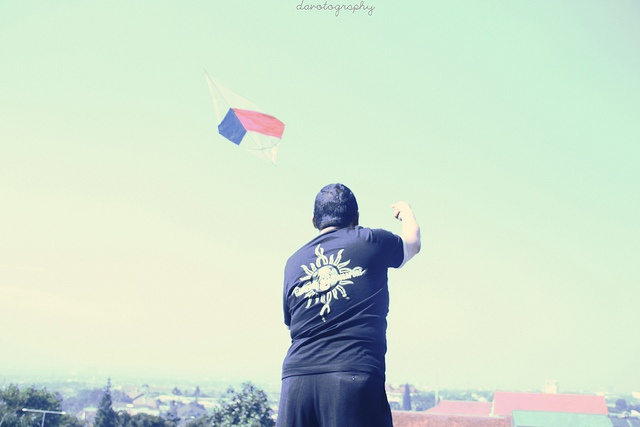Describe the objects in this image and their specific colors. I can see people in beige, navy, gray, and darkblue tones and kite in beige, lightpink, and gray tones in this image. 